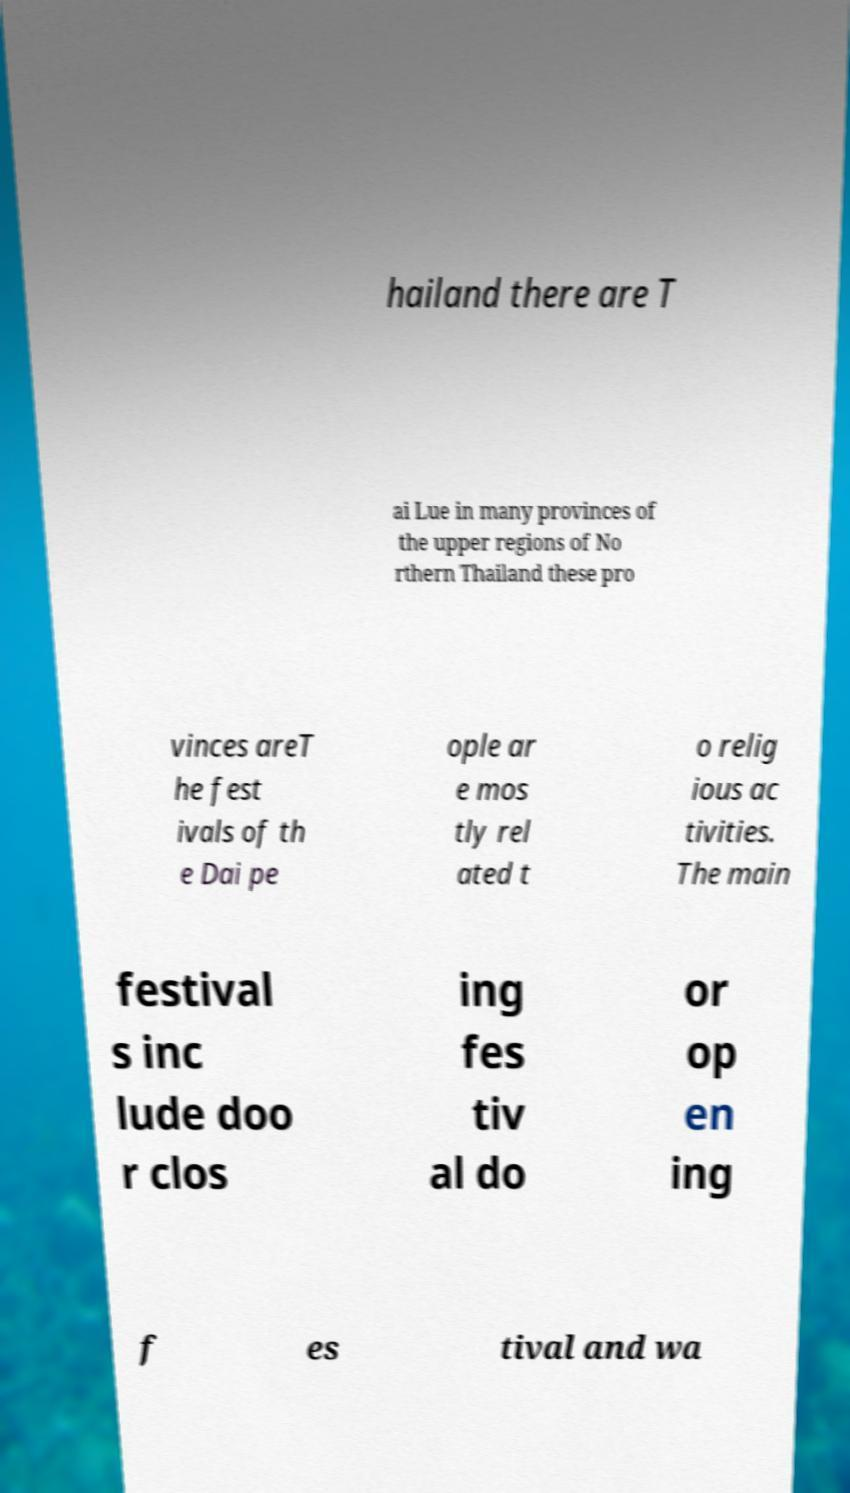Please identify and transcribe the text found in this image. hailand there are T ai Lue in many provinces of the upper regions of No rthern Thailand these pro vinces areT he fest ivals of th e Dai pe ople ar e mos tly rel ated t o relig ious ac tivities. The main festival s inc lude doo r clos ing fes tiv al do or op en ing f es tival and wa 